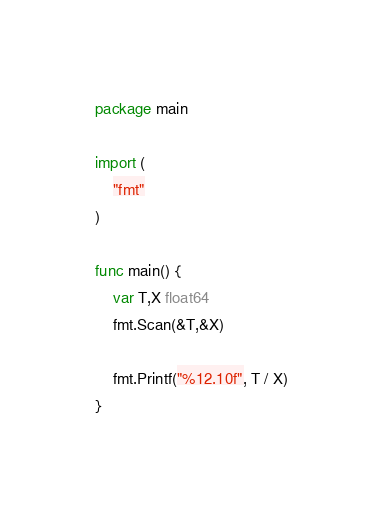<code> <loc_0><loc_0><loc_500><loc_500><_Go_>package main

import (
	"fmt"
)

func main() {
	var T,X float64
	fmt.Scan(&T,&X)
	
	fmt.Printf("%12.10f", T / X)
}</code> 